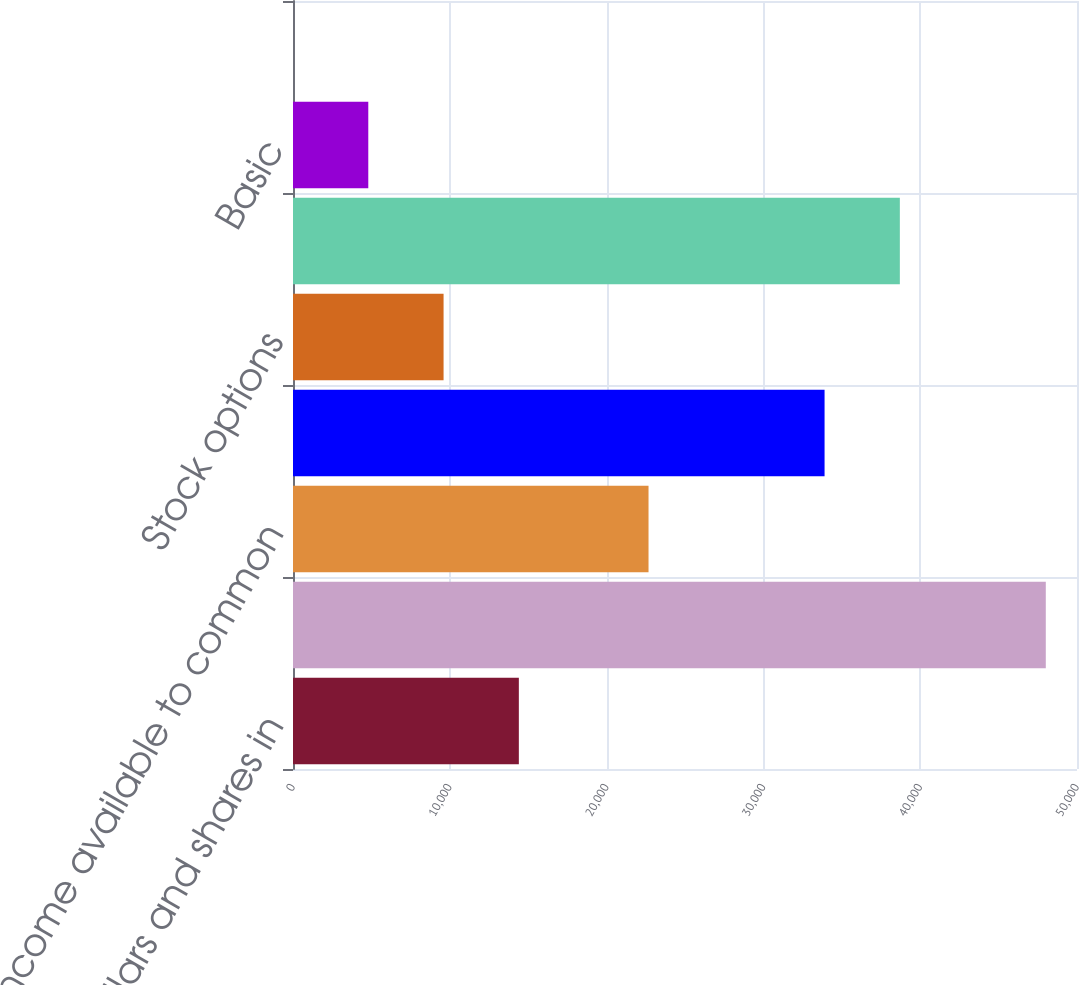Convert chart. <chart><loc_0><loc_0><loc_500><loc_500><bar_chart><fcel>(Dollars and shares in<fcel>Net income attributable to<fcel>Net income available to common<fcel>Weighted average common shares<fcel>Stock options<fcel>Denominator for diluted<fcel>Basic<fcel>Diluted<nl><fcel>14403.5<fcel>48010<fcel>22674<fcel>33901<fcel>9602.52<fcel>38701.9<fcel>4801.59<fcel>0.66<nl></chart> 